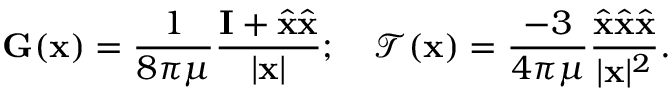<formula> <loc_0><loc_0><loc_500><loc_500>G ( x ) = \frac { 1 } { 8 \pi \mu } \frac { I + \hat { x } \hat { x } } { | x | } ; \mathcal { T } ( x ) = \frac { - 3 } { 4 \pi \mu } \frac { \hat { x } \hat { x } \hat { x } } { | x | ^ { 2 } } .</formula> 